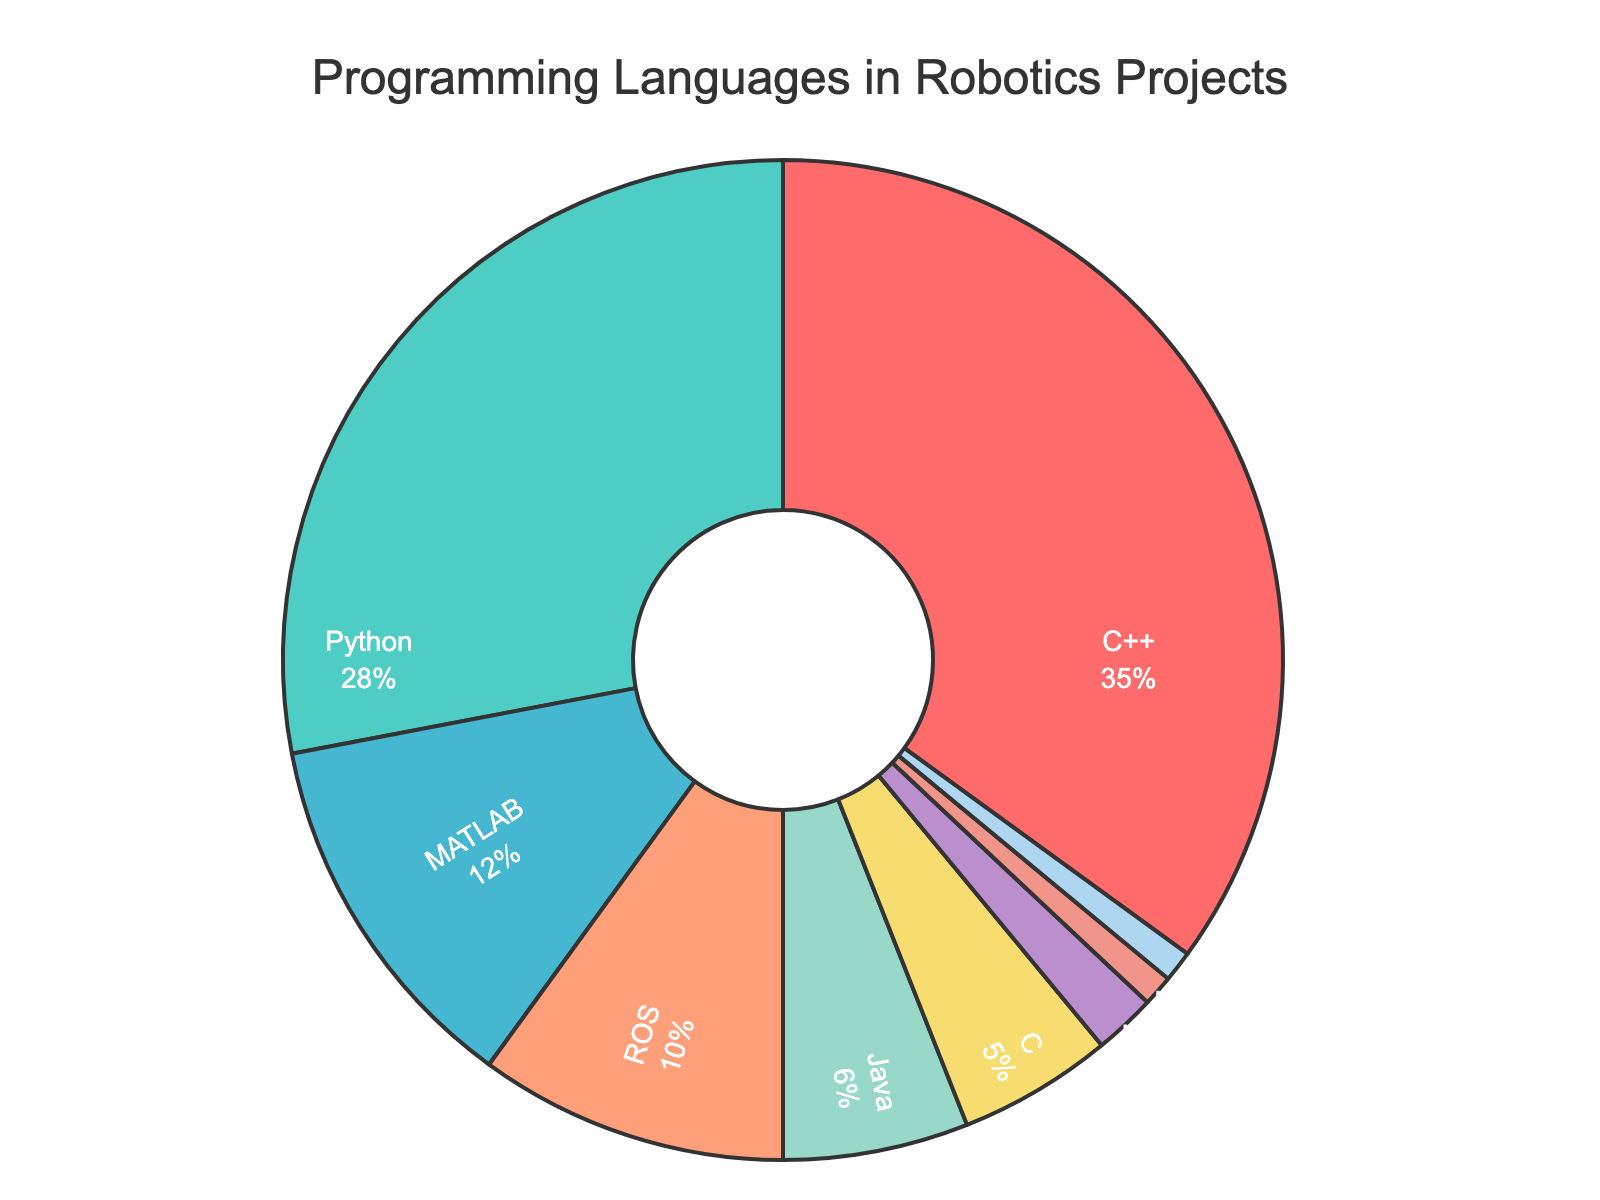What is the most used programming language in robotics projects? The biggest section of the pie chart corresponds to C++, indicating it is the most used programming language in robotics projects.
Answer: C++ Which programming language is used more, Python or MATLAB? By comparing the two sections of the pie chart, we see that Python has a larger percentage (28%) compared to MATLAB (12%).
Answer: Python What is the combined percentage of MATLAB and ROS? Add the percentages of MATLAB (12%) and ROS (10%) together to get the combined percentage: 12 + 10 = 22%.
Answer: 22% Is Java used more than C? By comparing the two sections of the pie chart, Java has a greater percentage (6%) than C (5%).
Answer: Yes Which section of the pie chart is represented by the green color? The green color represents Python, as we can visually identify from the chart.
Answer: Python What is the total percentage of all programming languages used less than 5%? Sum the percentages for languages used less than 5%: LabVIEW (2%), Lua (1%), Assembly (1%). 2 + 1 + 1 = 4%.
Answer: 4% By how much does the percentage of C++ exceed that of Java? Subtract the percentage of Java (6%) from the percentage of C++ (35%): 35 - 6 = 29%.
Answer: 29% Is Python usage closer to C++ or to MATLAB? Calculate the differences: C++ (35%) versus Python (28%) gives 35 - 28 = 7%, and MATLAB (12%) versus Python (28%) gives 28 - 12 = 16%. Since 7% is smaller than 16%, Python is closer to C++ usage.
Answer: C++ Which programming languages combined make up half or more of the total percentage? Adding the percentages from the largest down until we reach 50% or more: C++ (35%) + Python (28%) = 63%, which is more than 50%, so C++ and Python combined make up half or more.
Answer: C++ and Python 